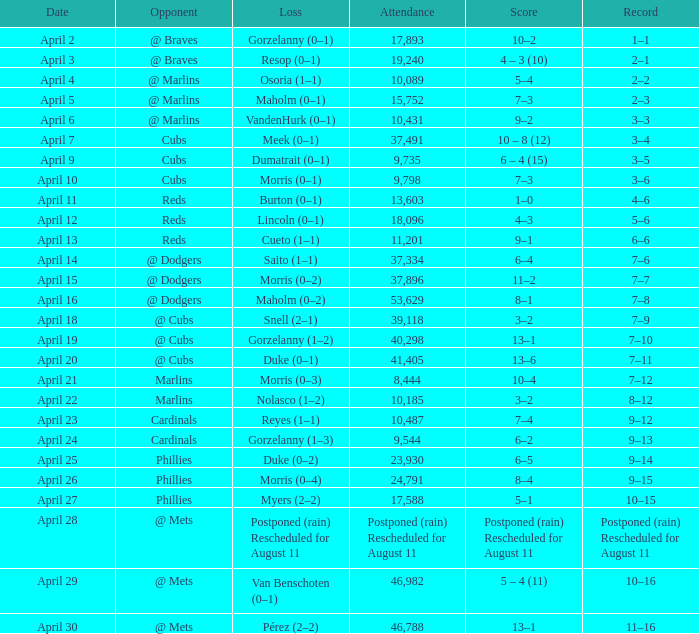What opponent had an attendance of 10,089? @ Marlins. 